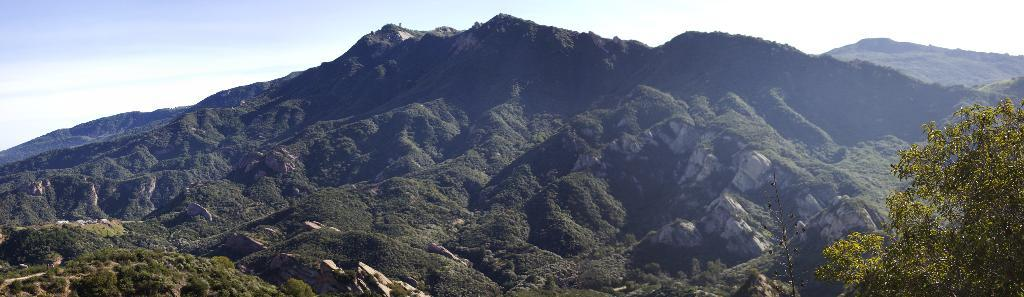What type of vegetation is on the right side of the image? There is a tree on the right side of the image. What geographical feature is located in the center of the image? There are mountains in the center of the image. What is visible in the image besides the tree and mountains? The sky is visible in the image. How many ducks are swimming in the river in the image? There is no river or ducks present in the image; it features a tree, mountains, and the sky. What type of stretch is being performed by the tree in the image? Trees do not perform stretches, as they are stationary plants. 